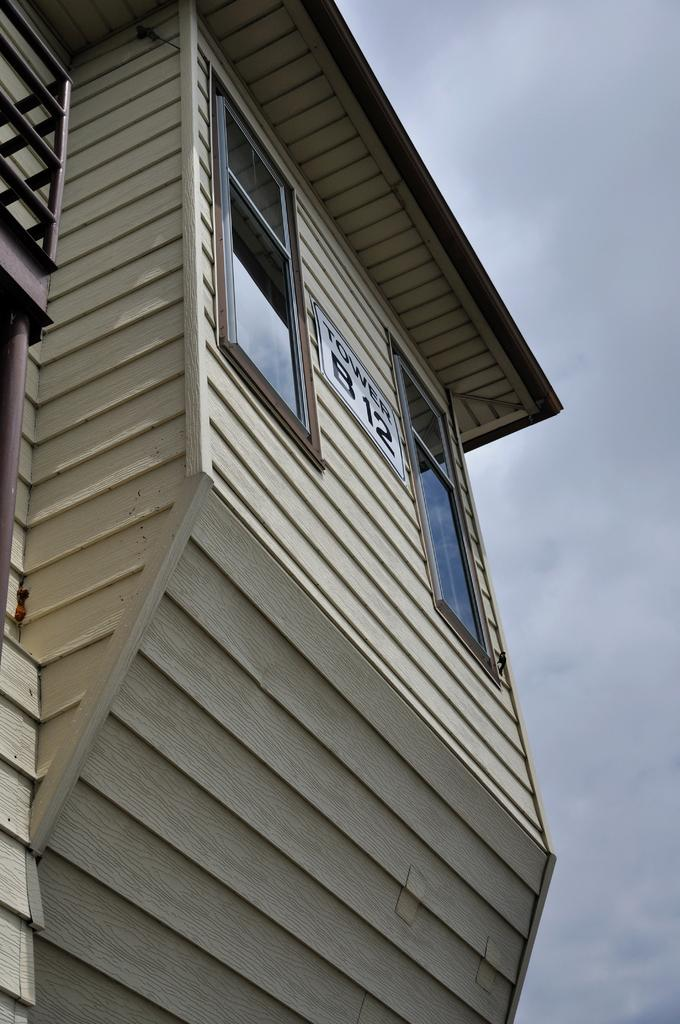What is the main structure in the image? There is a building in the image. How many windows can be seen on the building? The building has two windows. What can be seen in the background of the image? There is a sky visible in the background of the image. What is the condition of the sky in the image? There are clouds in the sky. How many docks are visible in the image? There are no docks present in the image. What type of team is working on sorting the clouds in the image? There is no team or sorting activity involving clouds in the image. 